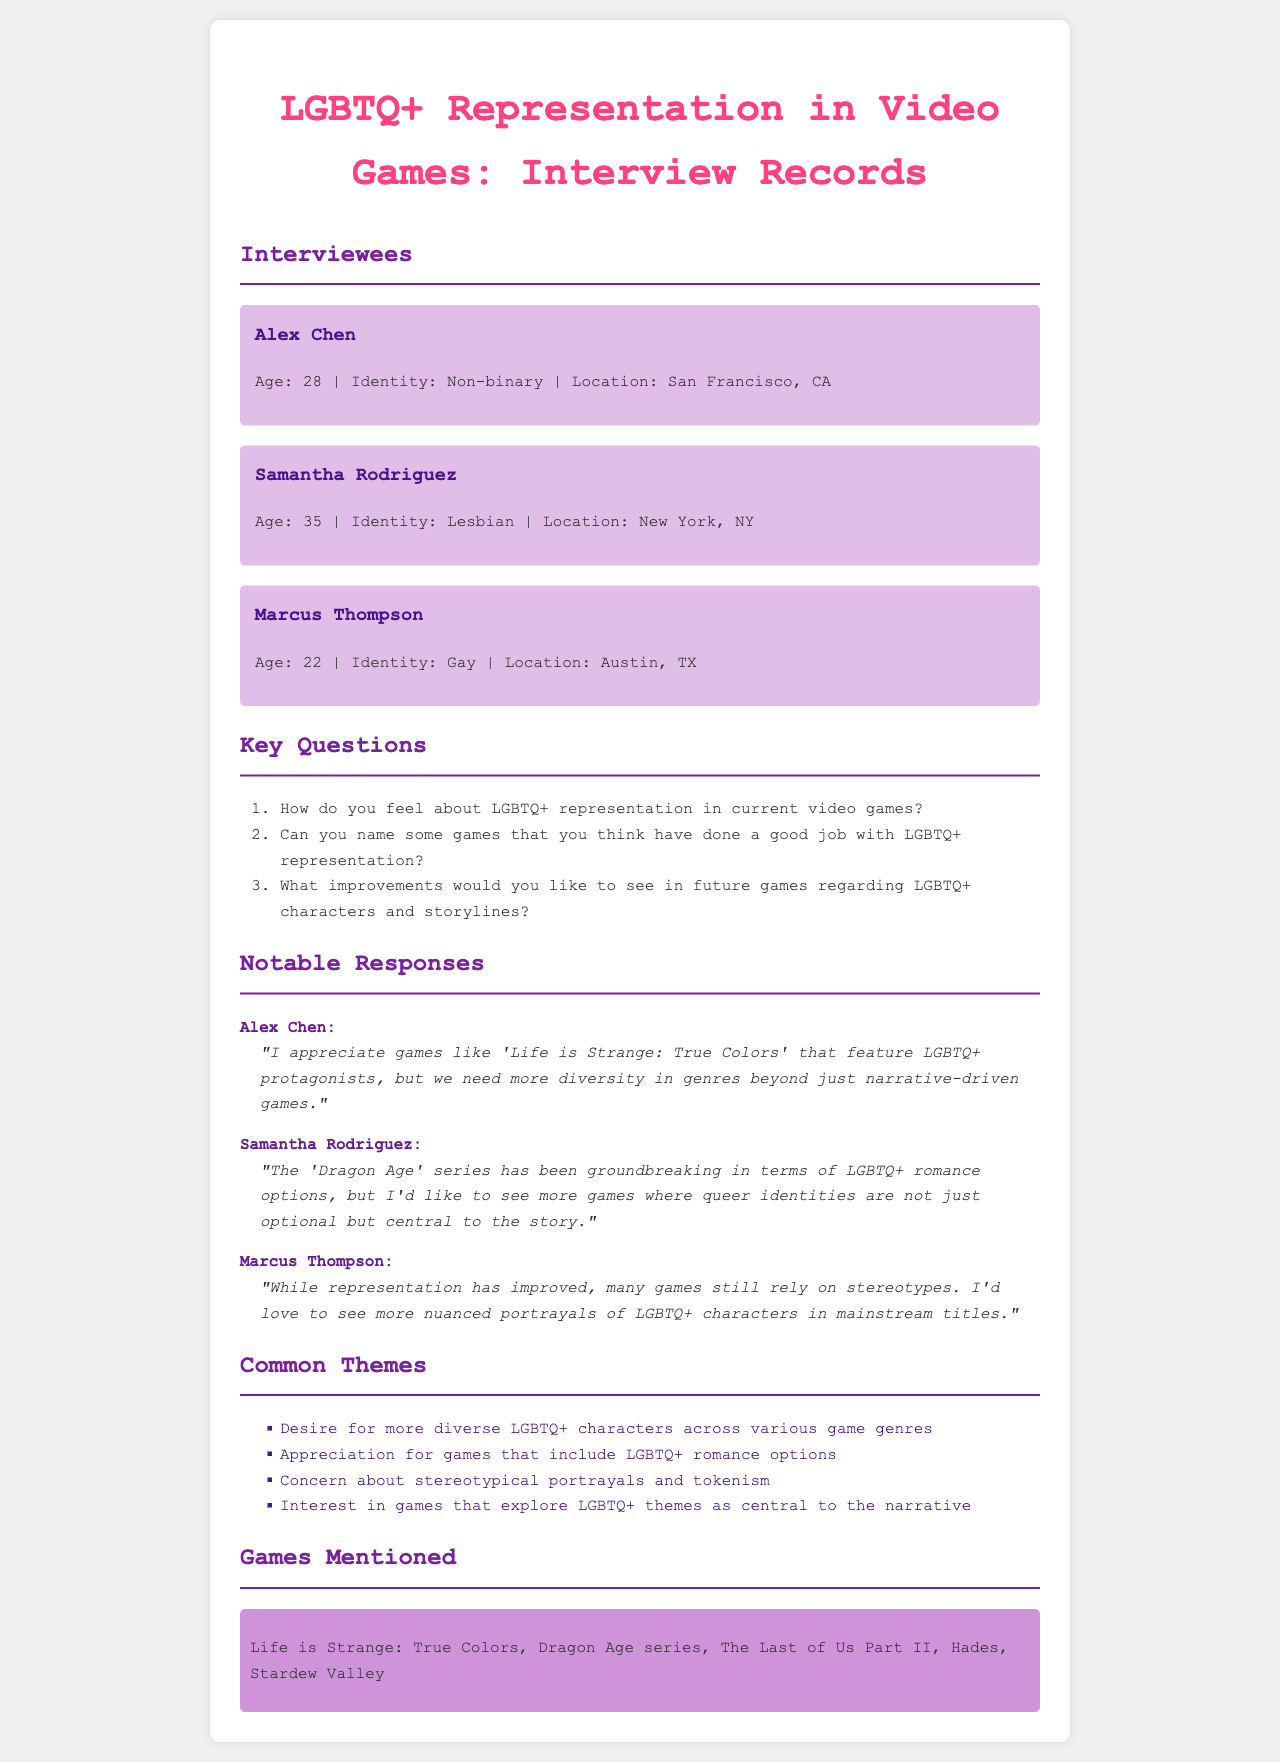What is the age of Alex Chen? The document states Alex Chen's age as 28.
Answer: 28 Which city is Samantha Rodriguez from? The document indicates that Samantha Rodriguez is from New York, NY.
Answer: New York, NY What video game is mentioned by Alex Chen? Alex Chen specifically mentions 'Life is Strange: True Colors.'
Answer: Life is Strange: True Colors How many interviewees are listed in the document? The document presents a total of three interviewees.
Answer: 3 What theme is expressed by Marcus Thompson regarding LGBTQ+ representation? Marcus Thompson expresses a concern about stereotypical portrayals and tokenism.
Answer: Stereotypical portrayals and tokenism Which game series does Samantha Rodriguez think has groundbreaking representation? Samantha Rodriguez believes the 'Dragon Age' series has groundbreaking representation.
Answer: Dragon Age series What improvement does Alex Chen suggest for genre diversity? Alex Chen suggests a need for more diversity in genres beyond narrative-driven games.
Answer: More diversity in genres In which section do we find common themes discussed? The common themes are discussed in the section labeled "Common Themes."
Answer: Common Themes What type of interviews are documented in this record? The record documents interviews conducted with LGBTQ+ gamers.
Answer: Interviews with LGBTQ+ gamers 